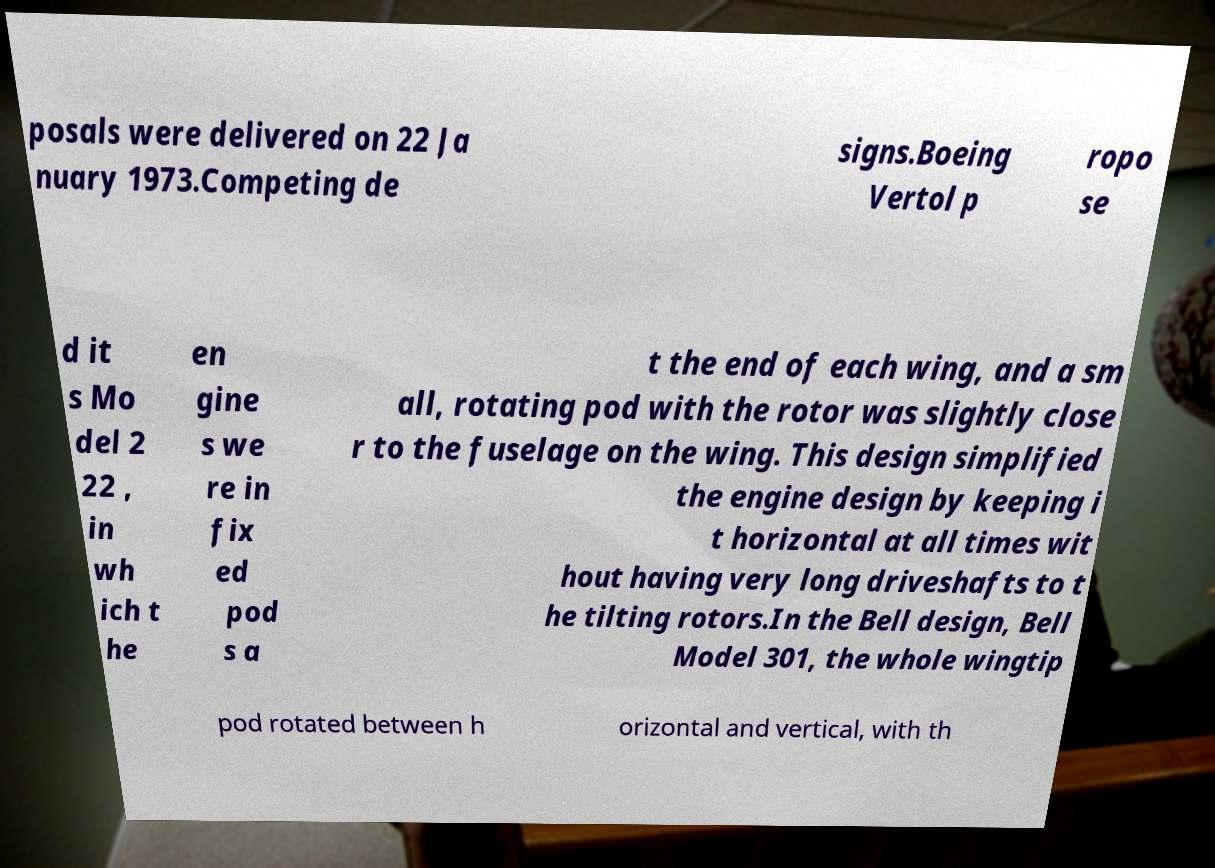Please identify and transcribe the text found in this image. posals were delivered on 22 Ja nuary 1973.Competing de signs.Boeing Vertol p ropo se d it s Mo del 2 22 , in wh ich t he en gine s we re in fix ed pod s a t the end of each wing, and a sm all, rotating pod with the rotor was slightly close r to the fuselage on the wing. This design simplified the engine design by keeping i t horizontal at all times wit hout having very long driveshafts to t he tilting rotors.In the Bell design, Bell Model 301, the whole wingtip pod rotated between h orizontal and vertical, with th 